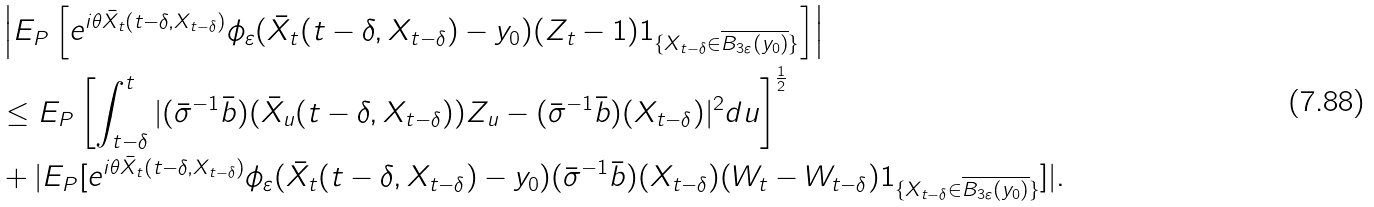<formula> <loc_0><loc_0><loc_500><loc_500>& \left | E _ { P } \left [ e ^ { i \theta \bar { X } _ { t } ( t - \delta , X _ { t - \delta } ) } \phi _ { \varepsilon } ( \bar { X } _ { t } ( t - \delta , X _ { t - \delta } ) - y _ { 0 } ) ( Z _ { t } - 1 ) 1 _ { \{ X _ { t - \delta } \in \overline { B _ { 3 \varepsilon } ( y _ { 0 } ) } \} } \right ] \right | \\ & \leq E _ { P } \left [ \int _ { t - \delta } ^ { t } | ( \bar { \sigma } ^ { - 1 } \bar { b } ) ( \bar { X } _ { u } ( t - \delta , X _ { t - \delta } ) ) Z _ { u } - ( \bar { \sigma } ^ { - 1 } \bar { b } ) ( X _ { t - \delta } ) | ^ { 2 } d u \right ] ^ { \frac { 1 } { 2 } } \\ & + | E _ { P } [ e ^ { i \theta \bar { X } _ { t } ( t - \delta , X _ { t - \delta } ) } \phi _ { \varepsilon } ( \bar { X } _ { t } ( t - \delta , X _ { t - \delta } ) - y _ { 0 } ) ( \bar { \sigma } ^ { - 1 } \bar { b } ) ( X _ { t - \delta } ) ( W _ { t } - W _ { t - \delta } ) 1 _ { \{ X _ { t - \delta } \in \overline { B _ { 3 \varepsilon } ( y _ { 0 } ) } \} } ] | .</formula> 